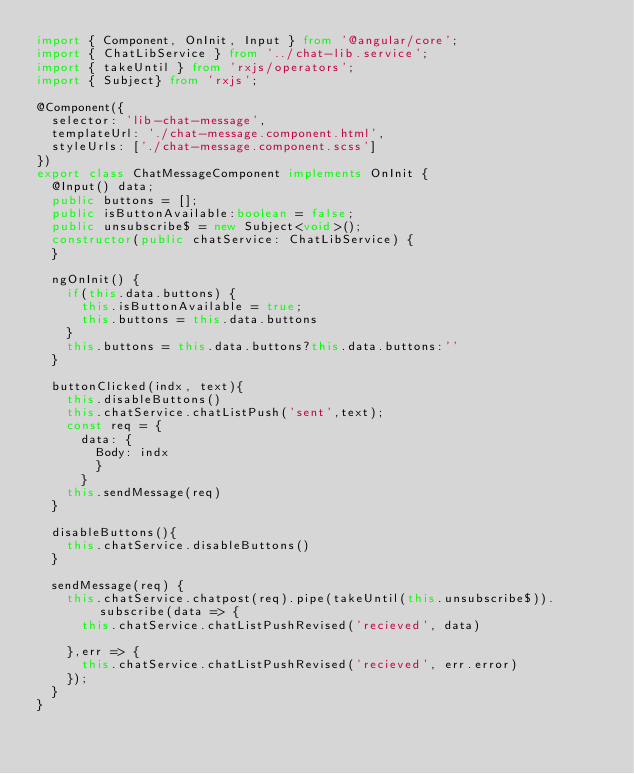Convert code to text. <code><loc_0><loc_0><loc_500><loc_500><_TypeScript_>import { Component, OnInit, Input } from '@angular/core';
import { ChatLibService } from '../chat-lib.service';
import { takeUntil } from 'rxjs/operators';
import { Subject} from 'rxjs';

@Component({
  selector: 'lib-chat-message',
  templateUrl: './chat-message.component.html',
  styleUrls: ['./chat-message.component.scss']
}) 
export class ChatMessageComponent implements OnInit {
  @Input() data;
  public buttons = [];
  public isButtonAvailable:boolean = false;
  public unsubscribe$ = new Subject<void>();
  constructor(public chatService: ChatLibService) { 
  }

  ngOnInit() {
    if(this.data.buttons) {
      this.isButtonAvailable = true;
      this.buttons = this.data.buttons
    }
    this.buttons = this.data.buttons?this.data.buttons:''
  }

  buttonClicked(indx, text){
    this.disableButtons()
    this.chatService.chatListPush('sent',text);
    const req = {
      data: {
        Body: indx
        }
      }
    this.sendMessage(req)
  }

  disableButtons(){
    this.chatService.disableButtons()
  }

  sendMessage(req) {
    this.chatService.chatpost(req).pipe(takeUntil(this.unsubscribe$)).subscribe(data => {
      this.chatService.chatListPushRevised('recieved', data)
      
    },err => {
      this.chatService.chatListPushRevised('recieved', err.error)
    });
  }
}
</code> 